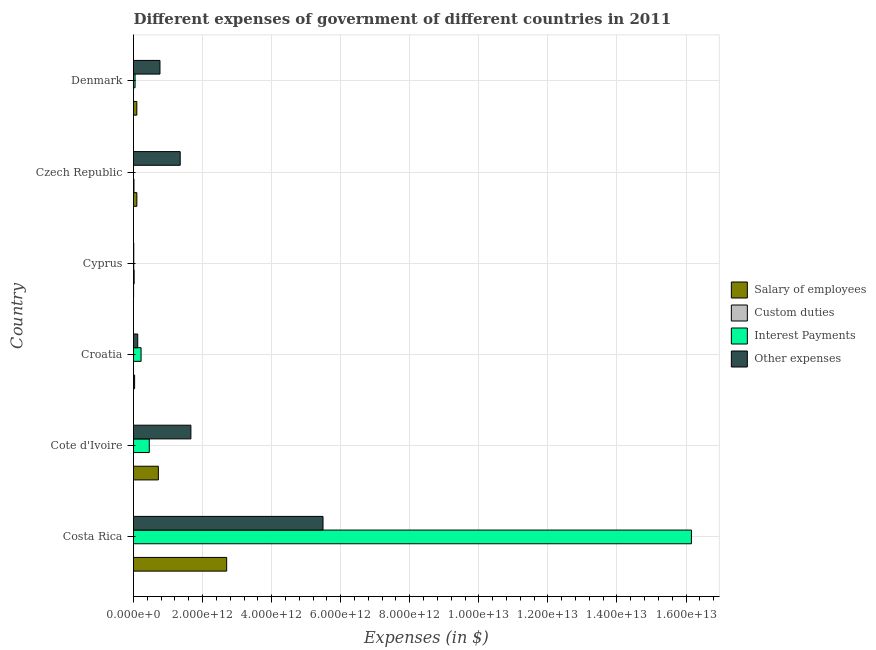How many different coloured bars are there?
Keep it short and to the point. 4. What is the label of the 3rd group of bars from the top?
Your response must be concise. Cyprus. In how many cases, is the number of bars for a given country not equal to the number of legend labels?
Offer a very short reply. 0. Across all countries, what is the maximum amount spent on interest payments?
Make the answer very short. 1.62e+13. Across all countries, what is the minimum amount spent on interest payments?
Your response must be concise. 3.98e+08. In which country was the amount spent on other expenses maximum?
Offer a very short reply. Costa Rica. In which country was the amount spent on other expenses minimum?
Your answer should be compact. Cyprus. What is the total amount spent on other expenses in the graph?
Provide a short and direct response. 9.40e+12. What is the difference between the amount spent on custom duties in Croatia and that in Denmark?
Provide a short and direct response. -1.14e+08. What is the difference between the amount spent on salary of employees in Costa Rica and the amount spent on custom duties in Denmark?
Offer a terse response. 2.70e+12. What is the average amount spent on other expenses per country?
Make the answer very short. 1.57e+12. What is the difference between the amount spent on custom duties and amount spent on other expenses in Czech Republic?
Keep it short and to the point. -1.34e+12. What is the ratio of the amount spent on other expenses in Croatia to that in Czech Republic?
Provide a short and direct response. 0.09. Is the difference between the amount spent on custom duties in Cote d'Ivoire and Denmark greater than the difference between the amount spent on salary of employees in Cote d'Ivoire and Denmark?
Ensure brevity in your answer.  No. What is the difference between the highest and the second highest amount spent on other expenses?
Provide a short and direct response. 3.83e+12. What is the difference between the highest and the lowest amount spent on custom duties?
Keep it short and to the point. 1.88e+1. In how many countries, is the amount spent on salary of employees greater than the average amount spent on salary of employees taken over all countries?
Give a very brief answer. 2. Is the sum of the amount spent on salary of employees in Croatia and Cyprus greater than the maximum amount spent on interest payments across all countries?
Offer a terse response. No. Is it the case that in every country, the sum of the amount spent on other expenses and amount spent on custom duties is greater than the sum of amount spent on interest payments and amount spent on salary of employees?
Give a very brief answer. No. What does the 1st bar from the top in Cyprus represents?
Offer a very short reply. Other expenses. What does the 1st bar from the bottom in Croatia represents?
Offer a very short reply. Salary of employees. Is it the case that in every country, the sum of the amount spent on salary of employees and amount spent on custom duties is greater than the amount spent on interest payments?
Keep it short and to the point. No. How many bars are there?
Ensure brevity in your answer.  24. What is the difference between two consecutive major ticks on the X-axis?
Your response must be concise. 2.00e+12. Does the graph contain any zero values?
Provide a succinct answer. No. Where does the legend appear in the graph?
Your response must be concise. Center right. What is the title of the graph?
Your response must be concise. Different expenses of government of different countries in 2011. What is the label or title of the X-axis?
Give a very brief answer. Expenses (in $). What is the label or title of the Y-axis?
Provide a succinct answer. Country. What is the Expenses (in $) of Salary of employees in Costa Rica?
Ensure brevity in your answer.  2.70e+12. What is the Expenses (in $) in Custom duties in Costa Rica?
Ensure brevity in your answer.  3.19e+07. What is the Expenses (in $) of Interest Payments in Costa Rica?
Your response must be concise. 1.62e+13. What is the Expenses (in $) in Other expenses in Costa Rica?
Provide a short and direct response. 5.49e+12. What is the Expenses (in $) of Salary of employees in Cote d'Ivoire?
Offer a very short reply. 7.20e+11. What is the Expenses (in $) in Interest Payments in Cote d'Ivoire?
Ensure brevity in your answer.  4.57e+11. What is the Expenses (in $) in Other expenses in Cote d'Ivoire?
Make the answer very short. 1.66e+12. What is the Expenses (in $) in Salary of employees in Croatia?
Provide a short and direct response. 3.20e+1. What is the Expenses (in $) of Custom duties in Croatia?
Provide a short and direct response. 5.38e+07. What is the Expenses (in $) in Interest Payments in Croatia?
Your answer should be compact. 2.19e+11. What is the Expenses (in $) in Other expenses in Croatia?
Provide a succinct answer. 1.22e+11. What is the Expenses (in $) in Salary of employees in Cyprus?
Ensure brevity in your answer.  2.73e+09. What is the Expenses (in $) in Custom duties in Cyprus?
Provide a succinct answer. 1.89e+1. What is the Expenses (in $) in Interest Payments in Cyprus?
Provide a short and direct response. 7.44e+09. What is the Expenses (in $) in Other expenses in Cyprus?
Your response must be concise. 7.69e+09. What is the Expenses (in $) of Salary of employees in Czech Republic?
Give a very brief answer. 9.72e+1. What is the Expenses (in $) of Custom duties in Czech Republic?
Make the answer very short. 1.35e+1. What is the Expenses (in $) of Interest Payments in Czech Republic?
Your answer should be compact. 3.98e+08. What is the Expenses (in $) of Other expenses in Czech Republic?
Provide a short and direct response. 1.35e+12. What is the Expenses (in $) of Salary of employees in Denmark?
Ensure brevity in your answer.  9.62e+1. What is the Expenses (in $) of Custom duties in Denmark?
Your answer should be very brief. 1.67e+08. What is the Expenses (in $) in Interest Payments in Denmark?
Make the answer very short. 4.50e+1. What is the Expenses (in $) of Other expenses in Denmark?
Ensure brevity in your answer.  7.66e+11. Across all countries, what is the maximum Expenses (in $) of Salary of employees?
Your answer should be very brief. 2.70e+12. Across all countries, what is the maximum Expenses (in $) in Custom duties?
Offer a terse response. 1.89e+1. Across all countries, what is the maximum Expenses (in $) in Interest Payments?
Provide a succinct answer. 1.62e+13. Across all countries, what is the maximum Expenses (in $) of Other expenses?
Offer a very short reply. 5.49e+12. Across all countries, what is the minimum Expenses (in $) of Salary of employees?
Ensure brevity in your answer.  2.73e+09. Across all countries, what is the minimum Expenses (in $) in Custom duties?
Your answer should be compact. 1.00e+06. Across all countries, what is the minimum Expenses (in $) of Interest Payments?
Give a very brief answer. 3.98e+08. Across all countries, what is the minimum Expenses (in $) of Other expenses?
Make the answer very short. 7.69e+09. What is the total Expenses (in $) in Salary of employees in the graph?
Your answer should be compact. 3.65e+12. What is the total Expenses (in $) in Custom duties in the graph?
Your response must be concise. 3.26e+1. What is the total Expenses (in $) in Interest Payments in the graph?
Offer a terse response. 1.69e+13. What is the total Expenses (in $) in Other expenses in the graph?
Your response must be concise. 9.40e+12. What is the difference between the Expenses (in $) of Salary of employees in Costa Rica and that in Cote d'Ivoire?
Make the answer very short. 1.98e+12. What is the difference between the Expenses (in $) of Custom duties in Costa Rica and that in Cote d'Ivoire?
Your response must be concise. 3.09e+07. What is the difference between the Expenses (in $) in Interest Payments in Costa Rica and that in Cote d'Ivoire?
Provide a short and direct response. 1.57e+13. What is the difference between the Expenses (in $) of Other expenses in Costa Rica and that in Cote d'Ivoire?
Your answer should be compact. 3.83e+12. What is the difference between the Expenses (in $) in Salary of employees in Costa Rica and that in Croatia?
Make the answer very short. 2.67e+12. What is the difference between the Expenses (in $) in Custom duties in Costa Rica and that in Croatia?
Ensure brevity in your answer.  -2.19e+07. What is the difference between the Expenses (in $) of Interest Payments in Costa Rica and that in Croatia?
Offer a terse response. 1.59e+13. What is the difference between the Expenses (in $) of Other expenses in Costa Rica and that in Croatia?
Your answer should be very brief. 5.37e+12. What is the difference between the Expenses (in $) in Salary of employees in Costa Rica and that in Cyprus?
Provide a succinct answer. 2.69e+12. What is the difference between the Expenses (in $) of Custom duties in Costa Rica and that in Cyprus?
Ensure brevity in your answer.  -1.88e+1. What is the difference between the Expenses (in $) in Interest Payments in Costa Rica and that in Cyprus?
Your answer should be very brief. 1.61e+13. What is the difference between the Expenses (in $) in Other expenses in Costa Rica and that in Cyprus?
Provide a short and direct response. 5.48e+12. What is the difference between the Expenses (in $) in Salary of employees in Costa Rica and that in Czech Republic?
Make the answer very short. 2.60e+12. What is the difference between the Expenses (in $) in Custom duties in Costa Rica and that in Czech Republic?
Make the answer very short. -1.34e+1. What is the difference between the Expenses (in $) of Interest Payments in Costa Rica and that in Czech Republic?
Provide a short and direct response. 1.62e+13. What is the difference between the Expenses (in $) in Other expenses in Costa Rica and that in Czech Republic?
Provide a short and direct response. 4.14e+12. What is the difference between the Expenses (in $) of Salary of employees in Costa Rica and that in Denmark?
Provide a succinct answer. 2.60e+12. What is the difference between the Expenses (in $) of Custom duties in Costa Rica and that in Denmark?
Your answer should be very brief. -1.35e+08. What is the difference between the Expenses (in $) of Interest Payments in Costa Rica and that in Denmark?
Make the answer very short. 1.61e+13. What is the difference between the Expenses (in $) of Other expenses in Costa Rica and that in Denmark?
Provide a short and direct response. 4.72e+12. What is the difference between the Expenses (in $) of Salary of employees in Cote d'Ivoire and that in Croatia?
Offer a very short reply. 6.88e+11. What is the difference between the Expenses (in $) of Custom duties in Cote d'Ivoire and that in Croatia?
Offer a very short reply. -5.28e+07. What is the difference between the Expenses (in $) in Interest Payments in Cote d'Ivoire and that in Croatia?
Your answer should be compact. 2.37e+11. What is the difference between the Expenses (in $) in Other expenses in Cote d'Ivoire and that in Croatia?
Give a very brief answer. 1.54e+12. What is the difference between the Expenses (in $) of Salary of employees in Cote d'Ivoire and that in Cyprus?
Provide a succinct answer. 7.17e+11. What is the difference between the Expenses (in $) of Custom duties in Cote d'Ivoire and that in Cyprus?
Keep it short and to the point. -1.88e+1. What is the difference between the Expenses (in $) of Interest Payments in Cote d'Ivoire and that in Cyprus?
Make the answer very short. 4.49e+11. What is the difference between the Expenses (in $) of Other expenses in Cote d'Ivoire and that in Cyprus?
Offer a very short reply. 1.65e+12. What is the difference between the Expenses (in $) of Salary of employees in Cote d'Ivoire and that in Czech Republic?
Your answer should be compact. 6.23e+11. What is the difference between the Expenses (in $) in Custom duties in Cote d'Ivoire and that in Czech Republic?
Offer a terse response. -1.35e+1. What is the difference between the Expenses (in $) in Interest Payments in Cote d'Ivoire and that in Czech Republic?
Offer a terse response. 4.56e+11. What is the difference between the Expenses (in $) in Other expenses in Cote d'Ivoire and that in Czech Republic?
Ensure brevity in your answer.  3.10e+11. What is the difference between the Expenses (in $) of Salary of employees in Cote d'Ivoire and that in Denmark?
Keep it short and to the point. 6.24e+11. What is the difference between the Expenses (in $) in Custom duties in Cote d'Ivoire and that in Denmark?
Make the answer very short. -1.66e+08. What is the difference between the Expenses (in $) in Interest Payments in Cote d'Ivoire and that in Denmark?
Give a very brief answer. 4.12e+11. What is the difference between the Expenses (in $) in Other expenses in Cote d'Ivoire and that in Denmark?
Make the answer very short. 8.96e+11. What is the difference between the Expenses (in $) in Salary of employees in Croatia and that in Cyprus?
Your response must be concise. 2.93e+1. What is the difference between the Expenses (in $) in Custom duties in Croatia and that in Cyprus?
Offer a very short reply. -1.88e+1. What is the difference between the Expenses (in $) of Interest Payments in Croatia and that in Cyprus?
Your response must be concise. 2.12e+11. What is the difference between the Expenses (in $) of Other expenses in Croatia and that in Cyprus?
Make the answer very short. 1.15e+11. What is the difference between the Expenses (in $) of Salary of employees in Croatia and that in Czech Republic?
Provide a short and direct response. -6.52e+1. What is the difference between the Expenses (in $) of Custom duties in Croatia and that in Czech Republic?
Offer a very short reply. -1.34e+1. What is the difference between the Expenses (in $) in Interest Payments in Croatia and that in Czech Republic?
Your response must be concise. 2.19e+11. What is the difference between the Expenses (in $) of Other expenses in Croatia and that in Czech Republic?
Offer a terse response. -1.23e+12. What is the difference between the Expenses (in $) in Salary of employees in Croatia and that in Denmark?
Offer a terse response. -6.42e+1. What is the difference between the Expenses (in $) of Custom duties in Croatia and that in Denmark?
Make the answer very short. -1.14e+08. What is the difference between the Expenses (in $) in Interest Payments in Croatia and that in Denmark?
Your answer should be compact. 1.74e+11. What is the difference between the Expenses (in $) of Other expenses in Croatia and that in Denmark?
Ensure brevity in your answer.  -6.44e+11. What is the difference between the Expenses (in $) in Salary of employees in Cyprus and that in Czech Republic?
Keep it short and to the point. -9.45e+1. What is the difference between the Expenses (in $) of Custom duties in Cyprus and that in Czech Republic?
Make the answer very short. 5.40e+09. What is the difference between the Expenses (in $) of Interest Payments in Cyprus and that in Czech Republic?
Your answer should be compact. 7.05e+09. What is the difference between the Expenses (in $) in Other expenses in Cyprus and that in Czech Republic?
Give a very brief answer. -1.34e+12. What is the difference between the Expenses (in $) of Salary of employees in Cyprus and that in Denmark?
Ensure brevity in your answer.  -9.34e+1. What is the difference between the Expenses (in $) in Custom duties in Cyprus and that in Denmark?
Offer a very short reply. 1.87e+1. What is the difference between the Expenses (in $) of Interest Payments in Cyprus and that in Denmark?
Your answer should be compact. -3.75e+1. What is the difference between the Expenses (in $) of Other expenses in Cyprus and that in Denmark?
Make the answer very short. -7.58e+11. What is the difference between the Expenses (in $) of Salary of employees in Czech Republic and that in Denmark?
Make the answer very short. 1.04e+09. What is the difference between the Expenses (in $) of Custom duties in Czech Republic and that in Denmark?
Offer a very short reply. 1.33e+1. What is the difference between the Expenses (in $) of Interest Payments in Czech Republic and that in Denmark?
Make the answer very short. -4.46e+1. What is the difference between the Expenses (in $) of Other expenses in Czech Republic and that in Denmark?
Your response must be concise. 5.86e+11. What is the difference between the Expenses (in $) in Salary of employees in Costa Rica and the Expenses (in $) in Custom duties in Cote d'Ivoire?
Your answer should be very brief. 2.70e+12. What is the difference between the Expenses (in $) in Salary of employees in Costa Rica and the Expenses (in $) in Interest Payments in Cote d'Ivoire?
Offer a terse response. 2.24e+12. What is the difference between the Expenses (in $) of Salary of employees in Costa Rica and the Expenses (in $) of Other expenses in Cote d'Ivoire?
Give a very brief answer. 1.04e+12. What is the difference between the Expenses (in $) of Custom duties in Costa Rica and the Expenses (in $) of Interest Payments in Cote d'Ivoire?
Your answer should be very brief. -4.57e+11. What is the difference between the Expenses (in $) in Custom duties in Costa Rica and the Expenses (in $) in Other expenses in Cote d'Ivoire?
Offer a terse response. -1.66e+12. What is the difference between the Expenses (in $) of Interest Payments in Costa Rica and the Expenses (in $) of Other expenses in Cote d'Ivoire?
Your answer should be compact. 1.45e+13. What is the difference between the Expenses (in $) of Salary of employees in Costa Rica and the Expenses (in $) of Custom duties in Croatia?
Your response must be concise. 2.70e+12. What is the difference between the Expenses (in $) of Salary of employees in Costa Rica and the Expenses (in $) of Interest Payments in Croatia?
Give a very brief answer. 2.48e+12. What is the difference between the Expenses (in $) of Salary of employees in Costa Rica and the Expenses (in $) of Other expenses in Croatia?
Provide a succinct answer. 2.58e+12. What is the difference between the Expenses (in $) of Custom duties in Costa Rica and the Expenses (in $) of Interest Payments in Croatia?
Your response must be concise. -2.19e+11. What is the difference between the Expenses (in $) in Custom duties in Costa Rica and the Expenses (in $) in Other expenses in Croatia?
Your answer should be very brief. -1.22e+11. What is the difference between the Expenses (in $) of Interest Payments in Costa Rica and the Expenses (in $) of Other expenses in Croatia?
Make the answer very short. 1.60e+13. What is the difference between the Expenses (in $) of Salary of employees in Costa Rica and the Expenses (in $) of Custom duties in Cyprus?
Provide a short and direct response. 2.68e+12. What is the difference between the Expenses (in $) of Salary of employees in Costa Rica and the Expenses (in $) of Interest Payments in Cyprus?
Provide a short and direct response. 2.69e+12. What is the difference between the Expenses (in $) of Salary of employees in Costa Rica and the Expenses (in $) of Other expenses in Cyprus?
Your response must be concise. 2.69e+12. What is the difference between the Expenses (in $) of Custom duties in Costa Rica and the Expenses (in $) of Interest Payments in Cyprus?
Give a very brief answer. -7.41e+09. What is the difference between the Expenses (in $) in Custom duties in Costa Rica and the Expenses (in $) in Other expenses in Cyprus?
Make the answer very short. -7.66e+09. What is the difference between the Expenses (in $) of Interest Payments in Costa Rica and the Expenses (in $) of Other expenses in Cyprus?
Your answer should be very brief. 1.61e+13. What is the difference between the Expenses (in $) of Salary of employees in Costa Rica and the Expenses (in $) of Custom duties in Czech Republic?
Your answer should be compact. 2.68e+12. What is the difference between the Expenses (in $) in Salary of employees in Costa Rica and the Expenses (in $) in Interest Payments in Czech Republic?
Provide a succinct answer. 2.70e+12. What is the difference between the Expenses (in $) of Salary of employees in Costa Rica and the Expenses (in $) of Other expenses in Czech Republic?
Your answer should be very brief. 1.35e+12. What is the difference between the Expenses (in $) in Custom duties in Costa Rica and the Expenses (in $) in Interest Payments in Czech Republic?
Your answer should be very brief. -3.66e+08. What is the difference between the Expenses (in $) of Custom duties in Costa Rica and the Expenses (in $) of Other expenses in Czech Republic?
Your response must be concise. -1.35e+12. What is the difference between the Expenses (in $) in Interest Payments in Costa Rica and the Expenses (in $) in Other expenses in Czech Republic?
Ensure brevity in your answer.  1.48e+13. What is the difference between the Expenses (in $) in Salary of employees in Costa Rica and the Expenses (in $) in Custom duties in Denmark?
Your response must be concise. 2.70e+12. What is the difference between the Expenses (in $) of Salary of employees in Costa Rica and the Expenses (in $) of Interest Payments in Denmark?
Keep it short and to the point. 2.65e+12. What is the difference between the Expenses (in $) of Salary of employees in Costa Rica and the Expenses (in $) of Other expenses in Denmark?
Make the answer very short. 1.93e+12. What is the difference between the Expenses (in $) of Custom duties in Costa Rica and the Expenses (in $) of Interest Payments in Denmark?
Provide a short and direct response. -4.50e+1. What is the difference between the Expenses (in $) of Custom duties in Costa Rica and the Expenses (in $) of Other expenses in Denmark?
Make the answer very short. -7.66e+11. What is the difference between the Expenses (in $) of Interest Payments in Costa Rica and the Expenses (in $) of Other expenses in Denmark?
Your answer should be very brief. 1.54e+13. What is the difference between the Expenses (in $) of Salary of employees in Cote d'Ivoire and the Expenses (in $) of Custom duties in Croatia?
Your response must be concise. 7.20e+11. What is the difference between the Expenses (in $) of Salary of employees in Cote d'Ivoire and the Expenses (in $) of Interest Payments in Croatia?
Your answer should be very brief. 5.01e+11. What is the difference between the Expenses (in $) of Salary of employees in Cote d'Ivoire and the Expenses (in $) of Other expenses in Croatia?
Your answer should be compact. 5.97e+11. What is the difference between the Expenses (in $) of Custom duties in Cote d'Ivoire and the Expenses (in $) of Interest Payments in Croatia?
Make the answer very short. -2.19e+11. What is the difference between the Expenses (in $) of Custom duties in Cote d'Ivoire and the Expenses (in $) of Other expenses in Croatia?
Your answer should be compact. -1.22e+11. What is the difference between the Expenses (in $) in Interest Payments in Cote d'Ivoire and the Expenses (in $) in Other expenses in Croatia?
Offer a terse response. 3.34e+11. What is the difference between the Expenses (in $) in Salary of employees in Cote d'Ivoire and the Expenses (in $) in Custom duties in Cyprus?
Provide a succinct answer. 7.01e+11. What is the difference between the Expenses (in $) in Salary of employees in Cote d'Ivoire and the Expenses (in $) in Interest Payments in Cyprus?
Your answer should be very brief. 7.12e+11. What is the difference between the Expenses (in $) in Salary of employees in Cote d'Ivoire and the Expenses (in $) in Other expenses in Cyprus?
Give a very brief answer. 7.12e+11. What is the difference between the Expenses (in $) of Custom duties in Cote d'Ivoire and the Expenses (in $) of Interest Payments in Cyprus?
Provide a succinct answer. -7.44e+09. What is the difference between the Expenses (in $) of Custom duties in Cote d'Ivoire and the Expenses (in $) of Other expenses in Cyprus?
Keep it short and to the point. -7.69e+09. What is the difference between the Expenses (in $) of Interest Payments in Cote d'Ivoire and the Expenses (in $) of Other expenses in Cyprus?
Ensure brevity in your answer.  4.49e+11. What is the difference between the Expenses (in $) of Salary of employees in Cote d'Ivoire and the Expenses (in $) of Custom duties in Czech Republic?
Make the answer very short. 7.06e+11. What is the difference between the Expenses (in $) in Salary of employees in Cote d'Ivoire and the Expenses (in $) in Interest Payments in Czech Republic?
Offer a terse response. 7.19e+11. What is the difference between the Expenses (in $) in Salary of employees in Cote d'Ivoire and the Expenses (in $) in Other expenses in Czech Republic?
Your answer should be compact. -6.32e+11. What is the difference between the Expenses (in $) in Custom duties in Cote d'Ivoire and the Expenses (in $) in Interest Payments in Czech Republic?
Offer a terse response. -3.97e+08. What is the difference between the Expenses (in $) of Custom duties in Cote d'Ivoire and the Expenses (in $) of Other expenses in Czech Republic?
Your answer should be very brief. -1.35e+12. What is the difference between the Expenses (in $) of Interest Payments in Cote d'Ivoire and the Expenses (in $) of Other expenses in Czech Republic?
Provide a short and direct response. -8.95e+11. What is the difference between the Expenses (in $) of Salary of employees in Cote d'Ivoire and the Expenses (in $) of Custom duties in Denmark?
Make the answer very short. 7.20e+11. What is the difference between the Expenses (in $) in Salary of employees in Cote d'Ivoire and the Expenses (in $) in Interest Payments in Denmark?
Provide a succinct answer. 6.75e+11. What is the difference between the Expenses (in $) in Salary of employees in Cote d'Ivoire and the Expenses (in $) in Other expenses in Denmark?
Your answer should be very brief. -4.63e+1. What is the difference between the Expenses (in $) in Custom duties in Cote d'Ivoire and the Expenses (in $) in Interest Payments in Denmark?
Your answer should be very brief. -4.50e+1. What is the difference between the Expenses (in $) in Custom duties in Cote d'Ivoire and the Expenses (in $) in Other expenses in Denmark?
Give a very brief answer. -7.66e+11. What is the difference between the Expenses (in $) in Interest Payments in Cote d'Ivoire and the Expenses (in $) in Other expenses in Denmark?
Offer a very short reply. -3.09e+11. What is the difference between the Expenses (in $) of Salary of employees in Croatia and the Expenses (in $) of Custom duties in Cyprus?
Provide a short and direct response. 1.32e+1. What is the difference between the Expenses (in $) in Salary of employees in Croatia and the Expenses (in $) in Interest Payments in Cyprus?
Your answer should be very brief. 2.46e+1. What is the difference between the Expenses (in $) in Salary of employees in Croatia and the Expenses (in $) in Other expenses in Cyprus?
Your answer should be very brief. 2.43e+1. What is the difference between the Expenses (in $) in Custom duties in Croatia and the Expenses (in $) in Interest Payments in Cyprus?
Provide a succinct answer. -7.39e+09. What is the difference between the Expenses (in $) of Custom duties in Croatia and the Expenses (in $) of Other expenses in Cyprus?
Your response must be concise. -7.64e+09. What is the difference between the Expenses (in $) in Interest Payments in Croatia and the Expenses (in $) in Other expenses in Cyprus?
Offer a very short reply. 2.12e+11. What is the difference between the Expenses (in $) in Salary of employees in Croatia and the Expenses (in $) in Custom duties in Czech Republic?
Offer a terse response. 1.85e+1. What is the difference between the Expenses (in $) of Salary of employees in Croatia and the Expenses (in $) of Interest Payments in Czech Republic?
Your response must be concise. 3.16e+1. What is the difference between the Expenses (in $) in Salary of employees in Croatia and the Expenses (in $) in Other expenses in Czech Republic?
Offer a very short reply. -1.32e+12. What is the difference between the Expenses (in $) of Custom duties in Croatia and the Expenses (in $) of Interest Payments in Czech Republic?
Your answer should be compact. -3.44e+08. What is the difference between the Expenses (in $) of Custom duties in Croatia and the Expenses (in $) of Other expenses in Czech Republic?
Provide a succinct answer. -1.35e+12. What is the difference between the Expenses (in $) of Interest Payments in Croatia and the Expenses (in $) of Other expenses in Czech Republic?
Provide a short and direct response. -1.13e+12. What is the difference between the Expenses (in $) of Salary of employees in Croatia and the Expenses (in $) of Custom duties in Denmark?
Provide a succinct answer. 3.18e+1. What is the difference between the Expenses (in $) of Salary of employees in Croatia and the Expenses (in $) of Interest Payments in Denmark?
Provide a succinct answer. -1.30e+1. What is the difference between the Expenses (in $) in Salary of employees in Croatia and the Expenses (in $) in Other expenses in Denmark?
Your answer should be compact. -7.34e+11. What is the difference between the Expenses (in $) of Custom duties in Croatia and the Expenses (in $) of Interest Payments in Denmark?
Offer a very short reply. -4.49e+1. What is the difference between the Expenses (in $) of Custom duties in Croatia and the Expenses (in $) of Other expenses in Denmark?
Your answer should be very brief. -7.66e+11. What is the difference between the Expenses (in $) in Interest Payments in Croatia and the Expenses (in $) in Other expenses in Denmark?
Your answer should be compact. -5.47e+11. What is the difference between the Expenses (in $) of Salary of employees in Cyprus and the Expenses (in $) of Custom duties in Czech Republic?
Offer a very short reply. -1.07e+1. What is the difference between the Expenses (in $) in Salary of employees in Cyprus and the Expenses (in $) in Interest Payments in Czech Republic?
Your answer should be very brief. 2.33e+09. What is the difference between the Expenses (in $) in Salary of employees in Cyprus and the Expenses (in $) in Other expenses in Czech Republic?
Provide a succinct answer. -1.35e+12. What is the difference between the Expenses (in $) in Custom duties in Cyprus and the Expenses (in $) in Interest Payments in Czech Republic?
Your response must be concise. 1.85e+1. What is the difference between the Expenses (in $) in Custom duties in Cyprus and the Expenses (in $) in Other expenses in Czech Republic?
Provide a succinct answer. -1.33e+12. What is the difference between the Expenses (in $) in Interest Payments in Cyprus and the Expenses (in $) in Other expenses in Czech Republic?
Your answer should be very brief. -1.34e+12. What is the difference between the Expenses (in $) in Salary of employees in Cyprus and the Expenses (in $) in Custom duties in Denmark?
Keep it short and to the point. 2.56e+09. What is the difference between the Expenses (in $) of Salary of employees in Cyprus and the Expenses (in $) of Interest Payments in Denmark?
Your answer should be compact. -4.23e+1. What is the difference between the Expenses (in $) of Salary of employees in Cyprus and the Expenses (in $) of Other expenses in Denmark?
Your answer should be compact. -7.63e+11. What is the difference between the Expenses (in $) in Custom duties in Cyprus and the Expenses (in $) in Interest Payments in Denmark?
Your answer should be compact. -2.61e+1. What is the difference between the Expenses (in $) of Custom duties in Cyprus and the Expenses (in $) of Other expenses in Denmark?
Your answer should be very brief. -7.47e+11. What is the difference between the Expenses (in $) in Interest Payments in Cyprus and the Expenses (in $) in Other expenses in Denmark?
Offer a terse response. -7.59e+11. What is the difference between the Expenses (in $) of Salary of employees in Czech Republic and the Expenses (in $) of Custom duties in Denmark?
Ensure brevity in your answer.  9.71e+1. What is the difference between the Expenses (in $) of Salary of employees in Czech Republic and the Expenses (in $) of Interest Payments in Denmark?
Offer a very short reply. 5.22e+1. What is the difference between the Expenses (in $) of Salary of employees in Czech Republic and the Expenses (in $) of Other expenses in Denmark?
Keep it short and to the point. -6.69e+11. What is the difference between the Expenses (in $) of Custom duties in Czech Republic and the Expenses (in $) of Interest Payments in Denmark?
Provide a succinct answer. -3.15e+1. What is the difference between the Expenses (in $) in Custom duties in Czech Republic and the Expenses (in $) in Other expenses in Denmark?
Your answer should be compact. -7.53e+11. What is the difference between the Expenses (in $) in Interest Payments in Czech Republic and the Expenses (in $) in Other expenses in Denmark?
Offer a terse response. -7.66e+11. What is the average Expenses (in $) of Salary of employees per country?
Provide a short and direct response. 6.08e+11. What is the average Expenses (in $) of Custom duties per country?
Ensure brevity in your answer.  5.43e+09. What is the average Expenses (in $) of Interest Payments per country?
Your answer should be compact. 2.81e+12. What is the average Expenses (in $) in Other expenses per country?
Provide a short and direct response. 1.57e+12. What is the difference between the Expenses (in $) in Salary of employees and Expenses (in $) in Custom duties in Costa Rica?
Your answer should be very brief. 2.70e+12. What is the difference between the Expenses (in $) of Salary of employees and Expenses (in $) of Interest Payments in Costa Rica?
Your answer should be compact. -1.35e+13. What is the difference between the Expenses (in $) of Salary of employees and Expenses (in $) of Other expenses in Costa Rica?
Ensure brevity in your answer.  -2.79e+12. What is the difference between the Expenses (in $) in Custom duties and Expenses (in $) in Interest Payments in Costa Rica?
Your answer should be very brief. -1.62e+13. What is the difference between the Expenses (in $) in Custom duties and Expenses (in $) in Other expenses in Costa Rica?
Ensure brevity in your answer.  -5.49e+12. What is the difference between the Expenses (in $) in Interest Payments and Expenses (in $) in Other expenses in Costa Rica?
Make the answer very short. 1.07e+13. What is the difference between the Expenses (in $) in Salary of employees and Expenses (in $) in Custom duties in Cote d'Ivoire?
Offer a terse response. 7.20e+11. What is the difference between the Expenses (in $) in Salary of employees and Expenses (in $) in Interest Payments in Cote d'Ivoire?
Your answer should be very brief. 2.63e+11. What is the difference between the Expenses (in $) of Salary of employees and Expenses (in $) of Other expenses in Cote d'Ivoire?
Keep it short and to the point. -9.42e+11. What is the difference between the Expenses (in $) in Custom duties and Expenses (in $) in Interest Payments in Cote d'Ivoire?
Your response must be concise. -4.57e+11. What is the difference between the Expenses (in $) in Custom duties and Expenses (in $) in Other expenses in Cote d'Ivoire?
Keep it short and to the point. -1.66e+12. What is the difference between the Expenses (in $) of Interest Payments and Expenses (in $) of Other expenses in Cote d'Ivoire?
Provide a short and direct response. -1.21e+12. What is the difference between the Expenses (in $) of Salary of employees and Expenses (in $) of Custom duties in Croatia?
Provide a succinct answer. 3.20e+1. What is the difference between the Expenses (in $) of Salary of employees and Expenses (in $) of Interest Payments in Croatia?
Offer a very short reply. -1.87e+11. What is the difference between the Expenses (in $) of Salary of employees and Expenses (in $) of Other expenses in Croatia?
Provide a short and direct response. -9.04e+1. What is the difference between the Expenses (in $) of Custom duties and Expenses (in $) of Interest Payments in Croatia?
Your response must be concise. -2.19e+11. What is the difference between the Expenses (in $) in Custom duties and Expenses (in $) in Other expenses in Croatia?
Provide a short and direct response. -1.22e+11. What is the difference between the Expenses (in $) of Interest Payments and Expenses (in $) of Other expenses in Croatia?
Offer a terse response. 9.68e+1. What is the difference between the Expenses (in $) of Salary of employees and Expenses (in $) of Custom duties in Cyprus?
Your response must be concise. -1.61e+1. What is the difference between the Expenses (in $) in Salary of employees and Expenses (in $) in Interest Payments in Cyprus?
Give a very brief answer. -4.72e+09. What is the difference between the Expenses (in $) in Salary of employees and Expenses (in $) in Other expenses in Cyprus?
Make the answer very short. -4.97e+09. What is the difference between the Expenses (in $) in Custom duties and Expenses (in $) in Interest Payments in Cyprus?
Provide a succinct answer. 1.14e+1. What is the difference between the Expenses (in $) in Custom duties and Expenses (in $) in Other expenses in Cyprus?
Offer a very short reply. 1.12e+1. What is the difference between the Expenses (in $) in Interest Payments and Expenses (in $) in Other expenses in Cyprus?
Make the answer very short. -2.46e+08. What is the difference between the Expenses (in $) in Salary of employees and Expenses (in $) in Custom duties in Czech Republic?
Provide a succinct answer. 8.38e+1. What is the difference between the Expenses (in $) of Salary of employees and Expenses (in $) of Interest Payments in Czech Republic?
Offer a terse response. 9.68e+1. What is the difference between the Expenses (in $) in Salary of employees and Expenses (in $) in Other expenses in Czech Republic?
Offer a very short reply. -1.25e+12. What is the difference between the Expenses (in $) in Custom duties and Expenses (in $) in Interest Payments in Czech Republic?
Provide a succinct answer. 1.31e+1. What is the difference between the Expenses (in $) in Custom duties and Expenses (in $) in Other expenses in Czech Republic?
Keep it short and to the point. -1.34e+12. What is the difference between the Expenses (in $) of Interest Payments and Expenses (in $) of Other expenses in Czech Republic?
Your answer should be very brief. -1.35e+12. What is the difference between the Expenses (in $) of Salary of employees and Expenses (in $) of Custom duties in Denmark?
Offer a terse response. 9.60e+1. What is the difference between the Expenses (in $) in Salary of employees and Expenses (in $) in Interest Payments in Denmark?
Make the answer very short. 5.12e+1. What is the difference between the Expenses (in $) of Salary of employees and Expenses (in $) of Other expenses in Denmark?
Your answer should be very brief. -6.70e+11. What is the difference between the Expenses (in $) in Custom duties and Expenses (in $) in Interest Payments in Denmark?
Provide a succinct answer. -4.48e+1. What is the difference between the Expenses (in $) of Custom duties and Expenses (in $) of Other expenses in Denmark?
Provide a succinct answer. -7.66e+11. What is the difference between the Expenses (in $) of Interest Payments and Expenses (in $) of Other expenses in Denmark?
Make the answer very short. -7.21e+11. What is the ratio of the Expenses (in $) of Salary of employees in Costa Rica to that in Cote d'Ivoire?
Offer a very short reply. 3.75. What is the ratio of the Expenses (in $) in Custom duties in Costa Rica to that in Cote d'Ivoire?
Provide a succinct answer. 31.9. What is the ratio of the Expenses (in $) of Interest Payments in Costa Rica to that in Cote d'Ivoire?
Provide a short and direct response. 35.38. What is the ratio of the Expenses (in $) of Other expenses in Costa Rica to that in Cote d'Ivoire?
Your answer should be very brief. 3.3. What is the ratio of the Expenses (in $) of Salary of employees in Costa Rica to that in Croatia?
Your answer should be compact. 84.29. What is the ratio of the Expenses (in $) in Custom duties in Costa Rica to that in Croatia?
Make the answer very short. 0.59. What is the ratio of the Expenses (in $) in Interest Payments in Costa Rica to that in Croatia?
Offer a very short reply. 73.69. What is the ratio of the Expenses (in $) of Other expenses in Costa Rica to that in Croatia?
Keep it short and to the point. 44.82. What is the ratio of the Expenses (in $) of Salary of employees in Costa Rica to that in Cyprus?
Ensure brevity in your answer.  989.56. What is the ratio of the Expenses (in $) in Custom duties in Costa Rica to that in Cyprus?
Ensure brevity in your answer.  0. What is the ratio of the Expenses (in $) in Interest Payments in Costa Rica to that in Cyprus?
Ensure brevity in your answer.  2170.14. What is the ratio of the Expenses (in $) of Other expenses in Costa Rica to that in Cyprus?
Offer a terse response. 713.52. What is the ratio of the Expenses (in $) in Salary of employees in Costa Rica to that in Czech Republic?
Offer a terse response. 27.75. What is the ratio of the Expenses (in $) in Custom duties in Costa Rica to that in Czech Republic?
Give a very brief answer. 0. What is the ratio of the Expenses (in $) in Interest Payments in Costa Rica to that in Czech Republic?
Give a very brief answer. 4.06e+04. What is the ratio of the Expenses (in $) of Other expenses in Costa Rica to that in Czech Republic?
Your answer should be compact. 4.06. What is the ratio of the Expenses (in $) of Salary of employees in Costa Rica to that in Denmark?
Your response must be concise. 28.05. What is the ratio of the Expenses (in $) of Custom duties in Costa Rica to that in Denmark?
Provide a short and direct response. 0.19. What is the ratio of the Expenses (in $) of Interest Payments in Costa Rica to that in Denmark?
Your response must be concise. 359.13. What is the ratio of the Expenses (in $) of Other expenses in Costa Rica to that in Denmark?
Offer a terse response. 7.16. What is the ratio of the Expenses (in $) of Salary of employees in Cote d'Ivoire to that in Croatia?
Your response must be concise. 22.49. What is the ratio of the Expenses (in $) in Custom duties in Cote d'Ivoire to that in Croatia?
Your response must be concise. 0.02. What is the ratio of the Expenses (in $) in Interest Payments in Cote d'Ivoire to that in Croatia?
Offer a terse response. 2.08. What is the ratio of the Expenses (in $) of Other expenses in Cote d'Ivoire to that in Croatia?
Offer a terse response. 13.57. What is the ratio of the Expenses (in $) of Salary of employees in Cote d'Ivoire to that in Cyprus?
Make the answer very short. 264.05. What is the ratio of the Expenses (in $) in Custom duties in Cote d'Ivoire to that in Cyprus?
Ensure brevity in your answer.  0. What is the ratio of the Expenses (in $) in Interest Payments in Cote d'Ivoire to that in Cyprus?
Offer a terse response. 61.34. What is the ratio of the Expenses (in $) of Other expenses in Cote d'Ivoire to that in Cyprus?
Ensure brevity in your answer.  216.06. What is the ratio of the Expenses (in $) of Salary of employees in Cote d'Ivoire to that in Czech Republic?
Keep it short and to the point. 7.4. What is the ratio of the Expenses (in $) in Custom duties in Cote d'Ivoire to that in Czech Republic?
Provide a succinct answer. 0. What is the ratio of the Expenses (in $) of Interest Payments in Cote d'Ivoire to that in Czech Republic?
Offer a very short reply. 1147.37. What is the ratio of the Expenses (in $) in Other expenses in Cote d'Ivoire to that in Czech Republic?
Your answer should be very brief. 1.23. What is the ratio of the Expenses (in $) in Salary of employees in Cote d'Ivoire to that in Denmark?
Offer a terse response. 7.48. What is the ratio of the Expenses (in $) in Custom duties in Cote d'Ivoire to that in Denmark?
Give a very brief answer. 0.01. What is the ratio of the Expenses (in $) in Interest Payments in Cote d'Ivoire to that in Denmark?
Make the answer very short. 10.15. What is the ratio of the Expenses (in $) in Other expenses in Cote d'Ivoire to that in Denmark?
Offer a very short reply. 2.17. What is the ratio of the Expenses (in $) in Salary of employees in Croatia to that in Cyprus?
Give a very brief answer. 11.74. What is the ratio of the Expenses (in $) in Custom duties in Croatia to that in Cyprus?
Your response must be concise. 0. What is the ratio of the Expenses (in $) of Interest Payments in Croatia to that in Cyprus?
Offer a terse response. 29.45. What is the ratio of the Expenses (in $) of Other expenses in Croatia to that in Cyprus?
Provide a succinct answer. 15.92. What is the ratio of the Expenses (in $) in Salary of employees in Croatia to that in Czech Republic?
Your response must be concise. 0.33. What is the ratio of the Expenses (in $) of Custom duties in Croatia to that in Czech Republic?
Offer a very short reply. 0. What is the ratio of the Expenses (in $) in Interest Payments in Croatia to that in Czech Republic?
Make the answer very short. 550.88. What is the ratio of the Expenses (in $) of Other expenses in Croatia to that in Czech Republic?
Provide a short and direct response. 0.09. What is the ratio of the Expenses (in $) in Salary of employees in Croatia to that in Denmark?
Your answer should be compact. 0.33. What is the ratio of the Expenses (in $) of Custom duties in Croatia to that in Denmark?
Offer a terse response. 0.32. What is the ratio of the Expenses (in $) in Interest Payments in Croatia to that in Denmark?
Provide a succinct answer. 4.87. What is the ratio of the Expenses (in $) in Other expenses in Croatia to that in Denmark?
Provide a short and direct response. 0.16. What is the ratio of the Expenses (in $) in Salary of employees in Cyprus to that in Czech Republic?
Offer a very short reply. 0.03. What is the ratio of the Expenses (in $) in Custom duties in Cyprus to that in Czech Republic?
Offer a terse response. 1.4. What is the ratio of the Expenses (in $) of Interest Payments in Cyprus to that in Czech Republic?
Offer a terse response. 18.71. What is the ratio of the Expenses (in $) of Other expenses in Cyprus to that in Czech Republic?
Provide a succinct answer. 0.01. What is the ratio of the Expenses (in $) in Salary of employees in Cyprus to that in Denmark?
Offer a very short reply. 0.03. What is the ratio of the Expenses (in $) of Custom duties in Cyprus to that in Denmark?
Give a very brief answer. 112.67. What is the ratio of the Expenses (in $) of Interest Payments in Cyprus to that in Denmark?
Make the answer very short. 0.17. What is the ratio of the Expenses (in $) in Salary of employees in Czech Republic to that in Denmark?
Offer a very short reply. 1.01. What is the ratio of the Expenses (in $) of Custom duties in Czech Republic to that in Denmark?
Keep it short and to the point. 80.42. What is the ratio of the Expenses (in $) in Interest Payments in Czech Republic to that in Denmark?
Give a very brief answer. 0.01. What is the ratio of the Expenses (in $) of Other expenses in Czech Republic to that in Denmark?
Keep it short and to the point. 1.76. What is the difference between the highest and the second highest Expenses (in $) of Salary of employees?
Your response must be concise. 1.98e+12. What is the difference between the highest and the second highest Expenses (in $) in Custom duties?
Your answer should be compact. 5.40e+09. What is the difference between the highest and the second highest Expenses (in $) in Interest Payments?
Make the answer very short. 1.57e+13. What is the difference between the highest and the second highest Expenses (in $) of Other expenses?
Ensure brevity in your answer.  3.83e+12. What is the difference between the highest and the lowest Expenses (in $) in Salary of employees?
Provide a short and direct response. 2.69e+12. What is the difference between the highest and the lowest Expenses (in $) of Custom duties?
Your answer should be very brief. 1.88e+1. What is the difference between the highest and the lowest Expenses (in $) in Interest Payments?
Give a very brief answer. 1.62e+13. What is the difference between the highest and the lowest Expenses (in $) of Other expenses?
Make the answer very short. 5.48e+12. 